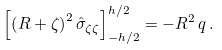<formula> <loc_0><loc_0><loc_500><loc_500>\left [ \left ( R + \zeta \right ) ^ { 2 } \hat { \sigma } _ { \zeta \zeta } \right ] _ { - h / 2 } ^ { h / 2 } = - R ^ { 2 } \, q \, .</formula> 